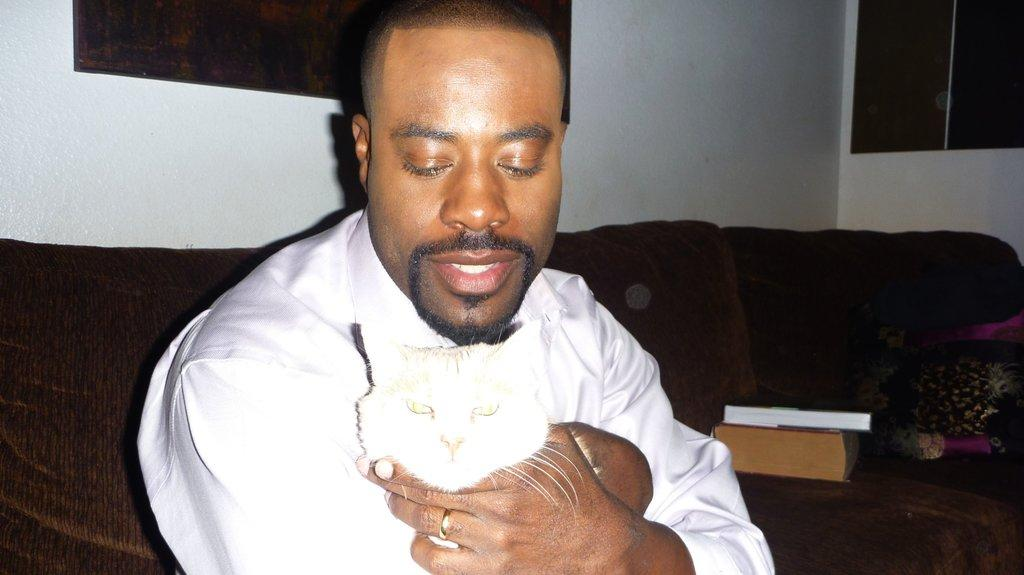Who or what is in the image? There is a person in the image. What is the person holding? The person is holding a cat. Where is the person sitting? The person is sitting on a sofa. What can be seen on the handle? There are books on the handle. What is visible in the background? There is a wall in the background. What type of fear can be seen on the cat's face in the image? There is no fear visible on the cat's face in the image, as the cat is being held by the person and appears calm. 